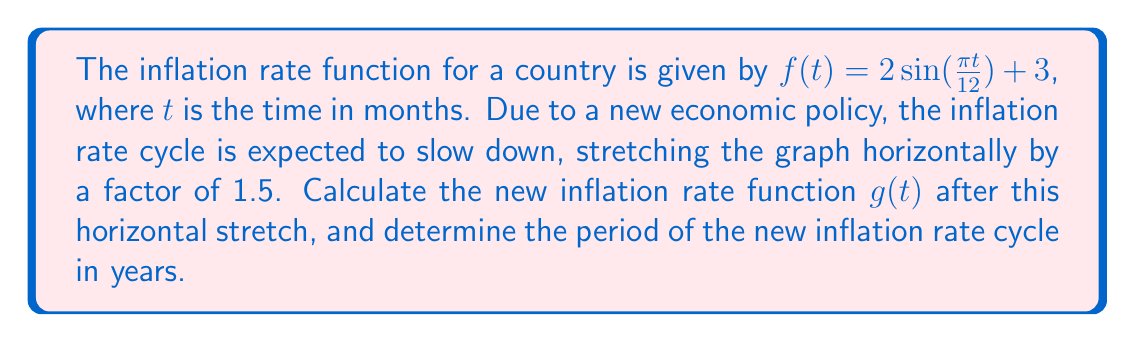Show me your answer to this math problem. 1) The general form of a horizontal stretch transformation is:
   $g(t) = f(\frac{t}{k})$, where $k$ is the stretch factor

2) In this case, $k = 1.5$, so we substitute $t$ with $\frac{t}{1.5}$ in the original function:
   $g(t) = 2\sin(\frac{\pi (\frac{t}{1.5})}{12}) + 3$

3) Simplify the argument of the sine function:
   $g(t) = 2\sin(\frac{\pi t}{18}) + 3$

4) To find the period of the new function, we need to solve:
   $\frac{\pi t}{18} = 2\pi$

5) Solving for $t$:
   $t = 36$ months

6) Convert the period to years:
   $36 \text{ months} = 3 \text{ years}$
Answer: $g(t) = 2\sin(\frac{\pi t}{18}) + 3$; Period = 3 years 